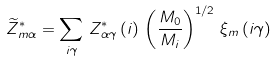<formula> <loc_0><loc_0><loc_500><loc_500>\widetilde { Z } ^ { * } _ { m \alpha } = \sum _ { i \gamma } \, Z ^ { * } _ { \alpha \gamma } \left ( i \right ) \, \left ( \frac { M _ { 0 } } { M _ { i } } \right ) ^ { 1 / 2 } \, \xi _ { m } \left ( i \gamma \right )</formula> 